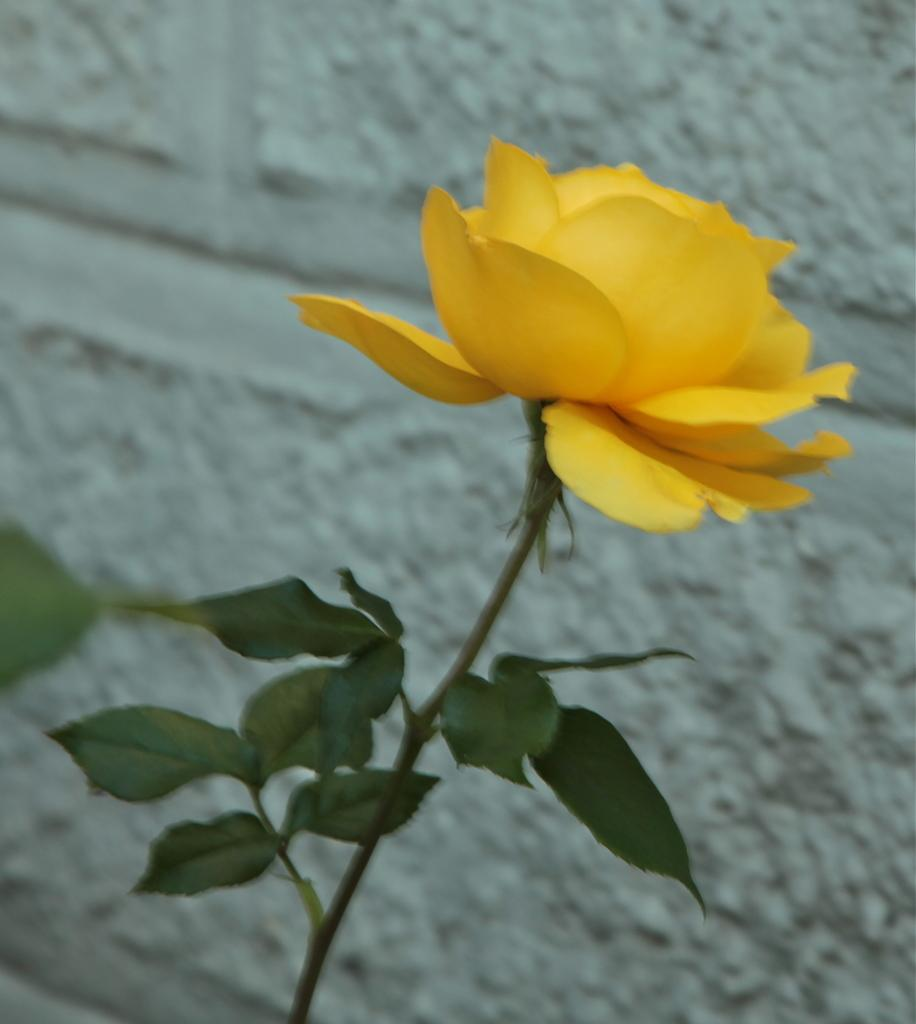What color is the flower in the image? The flower in the image is yellow. What other plant elements can be seen in the image? There are green leaves of a tree in the image. What is the color of the wall in the background of the image? The wall in the background of the image is white. How many toes does the flower have in the image? Flowers do not have toes, as they are not living organisms with limbs. 